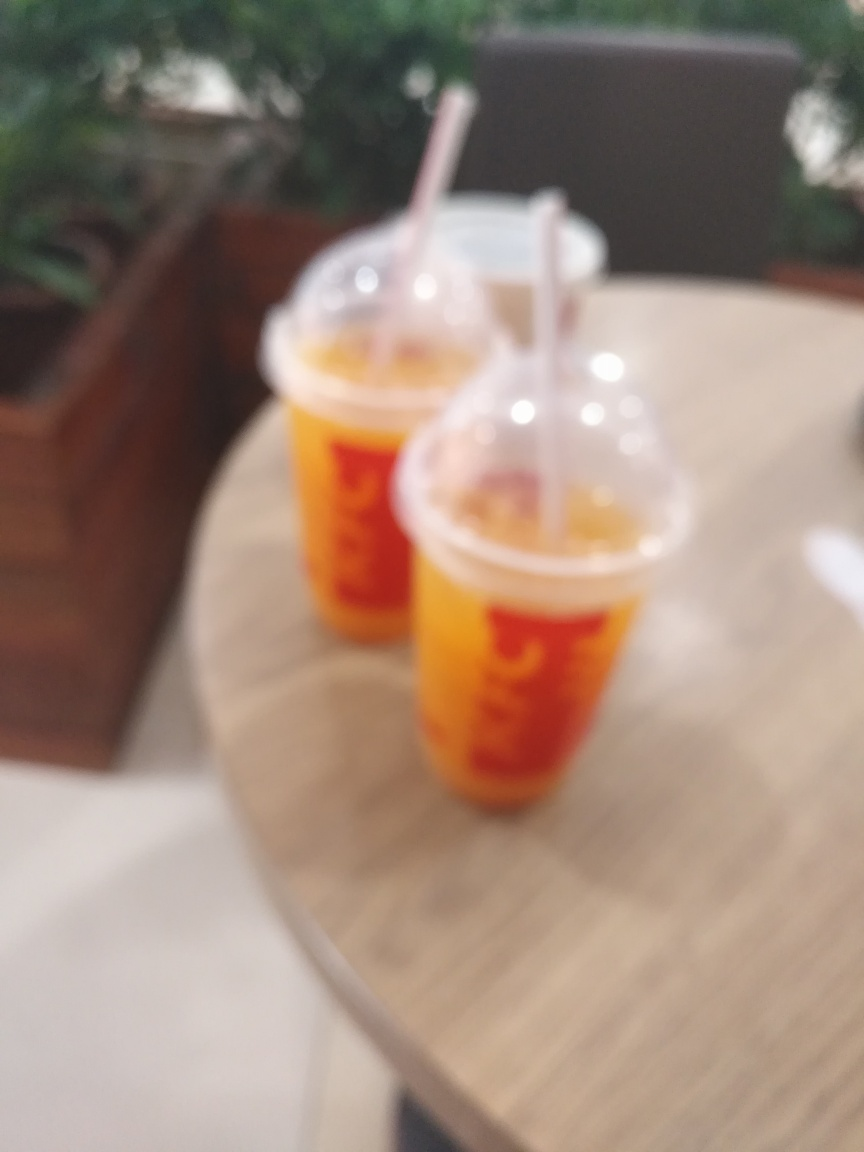What time of day do you think this photo was taken? Although the blurred quality makes it difficult to ascertain the time of day with accuracy, the ambient light visible in the upper part of the image seems to suggest it might be daytime. Is there anything in this image indicating it might be part of a social event? The image shows two cups, which might imply that more than one person is present, potentially indicating a social gathering. However, without additional contextual clues, it is difficult to confirm such an event. 